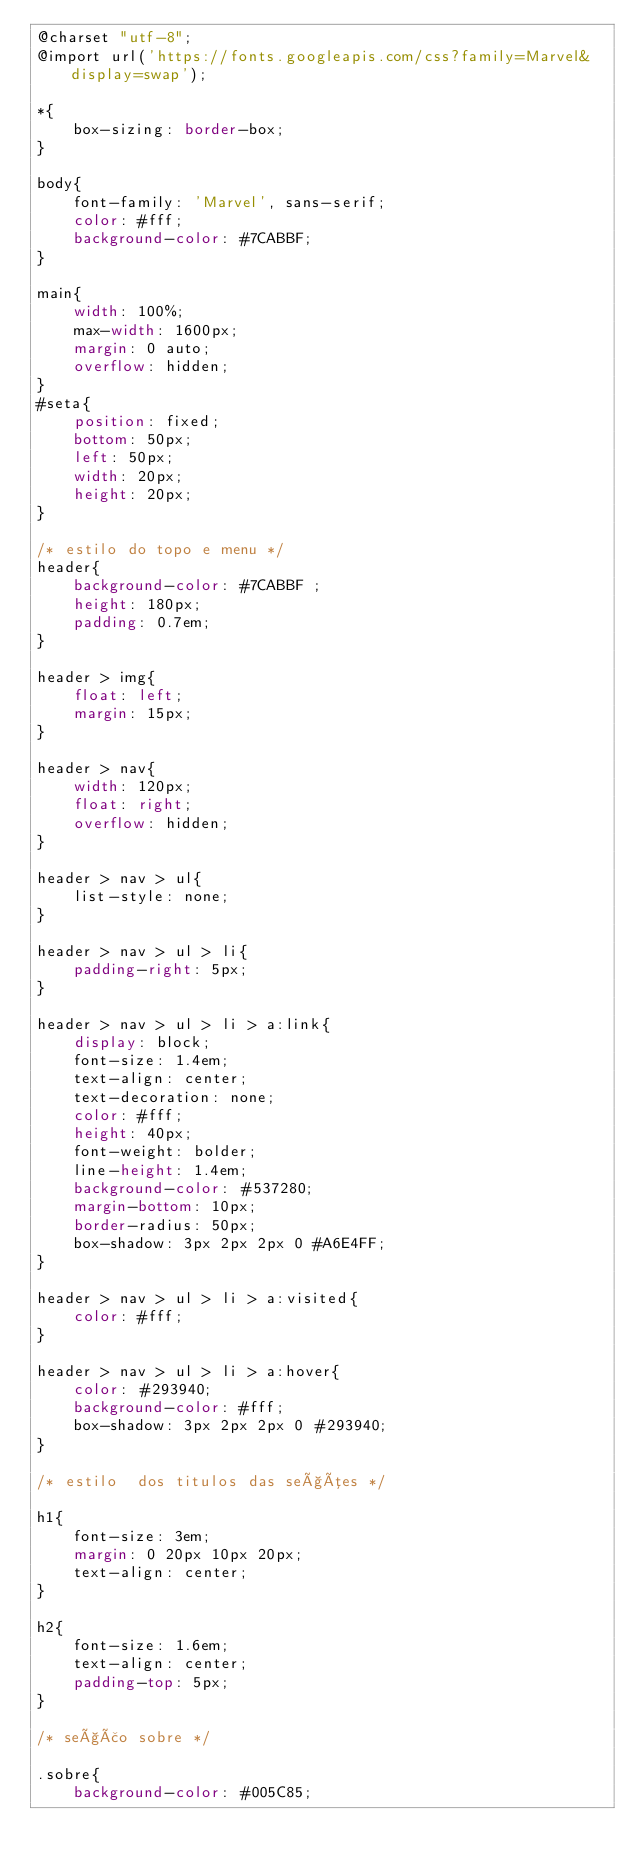<code> <loc_0><loc_0><loc_500><loc_500><_CSS_>@charset "utf-8";
@import url('https://fonts.googleapis.com/css?family=Marvel&display=swap');

*{
    box-sizing: border-box;
}

body{
    font-family: 'Marvel', sans-serif;
    color: #fff;
    background-color: #7CABBF;
}

main{
    width: 100%;
    max-width: 1600px;
    margin: 0 auto;
    overflow: hidden;
}
#seta{
    position: fixed;
    bottom: 50px;
    left: 50px;
    width: 20px;
    height: 20px;
}

/* estilo do topo e menu */
header{
    background-color: #7CABBF ;
    height: 180px;
    padding: 0.7em;        
}

header > img{
    float: left;    
    margin: 15px;
}

header > nav{
    width: 120px;
    float: right;
    overflow: hidden;
}

header > nav > ul{
    list-style: none;    
}

header > nav > ul > li{
    padding-right: 5px;
}

header > nav > ul > li > a:link{
    display: block;
    font-size: 1.4em;
    text-align: center;
    text-decoration: none;
    color: #fff;
    height: 40px;
    font-weight: bolder;
    line-height: 1.4em;
    background-color: #537280;
    margin-bottom: 10px;
    border-radius: 50px;
    box-shadow: 3px 2px 2px 0 #A6E4FF;
}

header > nav > ul > li > a:visited{
    color: #fff;
}

header > nav > ul > li > a:hover{
    color: #293940;
    background-color: #fff;
    box-shadow: 3px 2px 2px 0 #293940;
}

/* estilo  dos titulos das seções */

h1{
    font-size: 3em;
    margin: 0 20px 10px 20px;
    text-align: center;
}

h2{
    font-size: 1.6em;    
    text-align: center;
    padding-top: 5px;
}

/* seção sobre */

.sobre{
    background-color: #005C85;</code> 